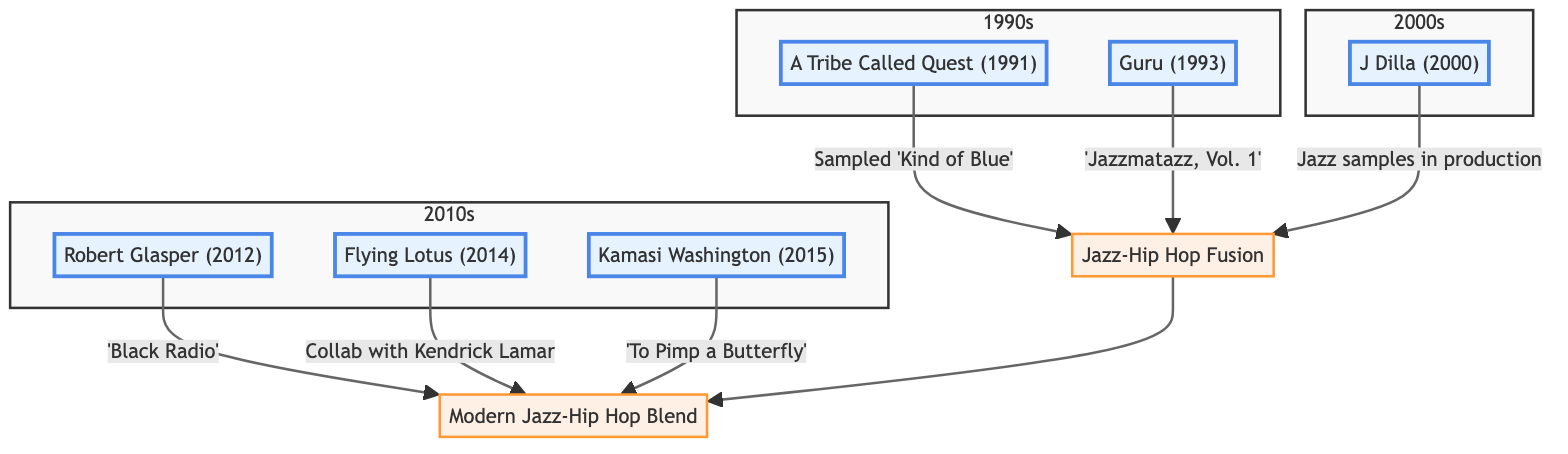What year did A Tribe Called Quest sample 'Kind of Blue'? The diagram specifies that A Tribe Called Quest's collaboration is from 1991, where they sampled 'Kind of Blue' by Miles Davis. Therefore, the answer is directly associated with the year in the diagram.
Answer: 1991 Which artist released 'Jazzmatazz, Vol. 1'? Guru is identified in the diagram as the artist who released 'Jazzmatazz, Vol. 1' in 1993, which is clearly labeled next to his node.
Answer: Guru How many collaborations are shown in the 2010s section? In the 2010s section, there are three nodes: Robert Glasper (2012), Flying Lotus (2014), and Kamasi Washington (2015). Counting these nodes provides the total number of collaborations in this timeframe.
Answer: 3 Which collaboration involved Kendrick Lamar? The nodes for Flying Lotus and Kamasi Washington both indicate collaborations involving Kendrick Lamar. Therefore, I can derive the answer by checking the respective collaboration labels related to Kendrick Lamar.
Answer: Flying Lotus, Kamasi Washington What is the main outcome of the jazz-hip hop fusion collaborations? The diagram indicates that all collaborations in the earlier years (1990s) lead to 'Jazz-Hip Hop Fusion,' which in turn connects to a broader blend shown by 'Modern Jazz-Hip Hop Blend' from collaborations in the 2010s. This shows the main outcome of a fusion category leading to a modern interpretation.
Answer: Jazz-Hip Hop Fusion What genre is associated with J Dilla's production? The diagram mentions that J Dilla incorporated jazz samples in his production for Slum Village, linking his work directly to the jazz genre based on the content of his collaboration.
Answer: Jazz How do collaborations from the 1990s relate to those in the 2010s? The flow in the diagram indicates that collaborations from the 1990s (A Tribe Called Quest and Guru) lead to a foundational 'Jazz-Hip Hop Fusion,' which then connects to modern collaborations in the 2010s (Robert Glasper, Flying Lotus, Kamasi Washington). This progression illustrates how early works influence later ones.
Answer: Through 'Jazz-Hip Hop Fusion' Which artist produced 'Black Radio'? The diagram explicitly states that Robert Glasper produced 'Black Radio' in 2012, making this information readily identifiable.
Answer: Robert Glasper 